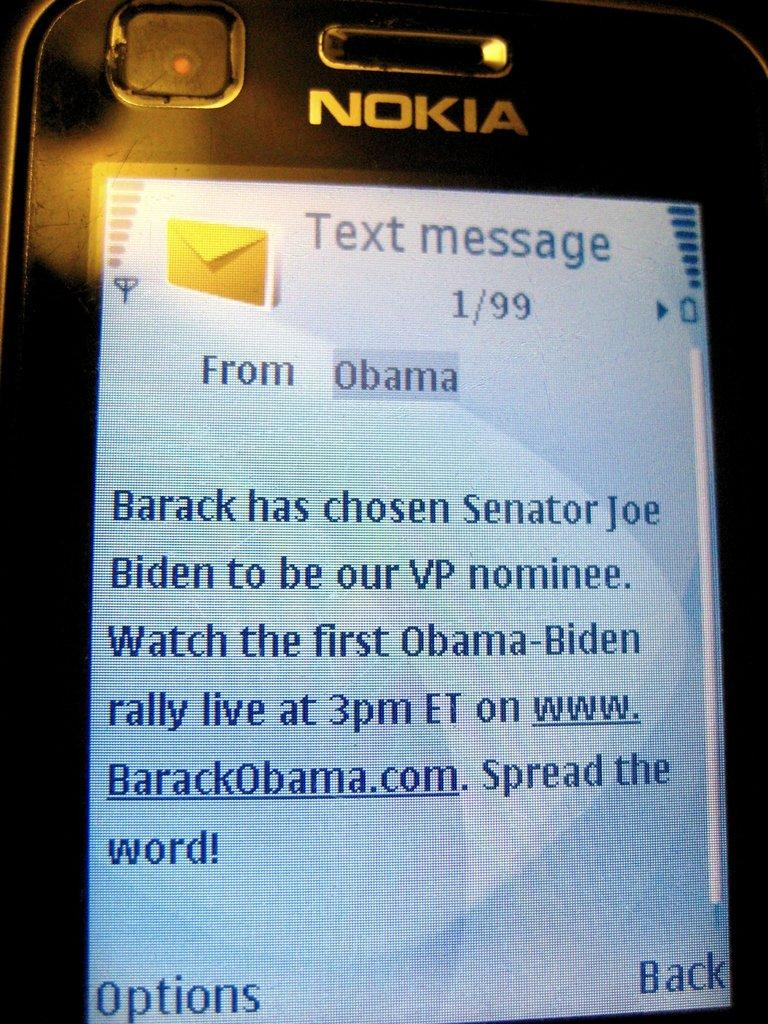<image>
Render a clear and concise summary of the photo. A text message that says it is from Obama 